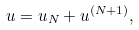Convert formula to latex. <formula><loc_0><loc_0><loc_500><loc_500>u = u _ { N } + u ^ { ( N + 1 ) } ,</formula> 